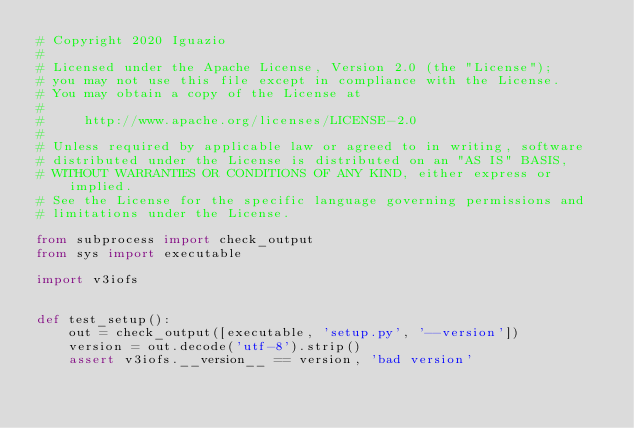<code> <loc_0><loc_0><loc_500><loc_500><_Python_># Copyright 2020 Iguazio
#
# Licensed under the Apache License, Version 2.0 (the "License");
# you may not use this file except in compliance with the License.
# You may obtain a copy of the License at
#
#     http://www.apache.org/licenses/LICENSE-2.0
#
# Unless required by applicable law or agreed to in writing, software
# distributed under the License is distributed on an "AS IS" BASIS,
# WITHOUT WARRANTIES OR CONDITIONS OF ANY KIND, either express or implied.
# See the License for the specific language governing permissions and
# limitations under the License.

from subprocess import check_output
from sys import executable

import v3iofs


def test_setup():
    out = check_output([executable, 'setup.py', '--version'])
    version = out.decode('utf-8').strip()
    assert v3iofs.__version__ == version, 'bad version'
</code> 